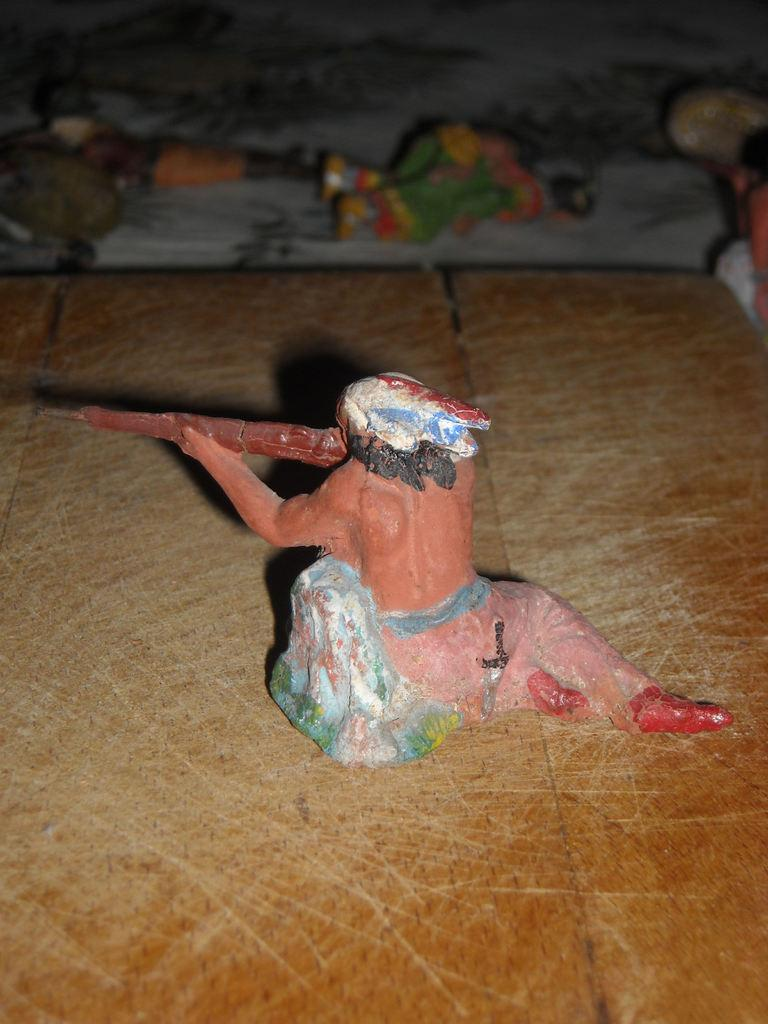What type of objects are present in the image? There are figurines in the image. Can you describe the surface of the figurine on the wooden surface? The figurine on the wooden surface is placed directly on the wood. How many figurines are on the cloth? There are three figurines on the cloth. What type of pickle is located in the middle of the image? There is no pickle present in the image; it only contains figurines. 